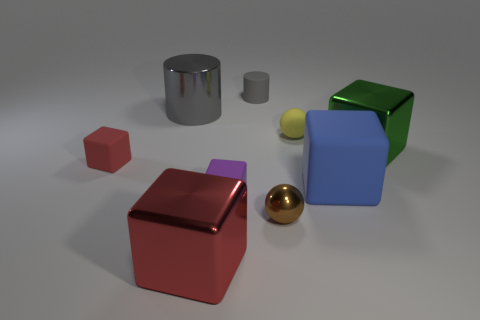How many red cubes have the same size as the gray metallic object?
Make the answer very short. 1. Does the big object that is in front of the small purple thing have the same material as the green block?
Keep it short and to the point. Yes. Are any tiny red balls visible?
Keep it short and to the point. No. There is a green object that is made of the same material as the small brown ball; what is its size?
Keep it short and to the point. Large. Is there a rubber cylinder that has the same color as the metallic cylinder?
Provide a short and direct response. Yes. Do the shiny cube left of the small brown thing and the tiny object that is left of the big red metal object have the same color?
Keep it short and to the point. Yes. What is the size of the other cylinder that is the same color as the big metallic cylinder?
Give a very brief answer. Small. Is there a big red ball made of the same material as the big blue cube?
Your answer should be compact. No. What color is the big matte object?
Keep it short and to the point. Blue. There is a ball in front of the metallic cube that is on the right side of the shiny block to the left of the rubber cylinder; how big is it?
Make the answer very short. Small. 